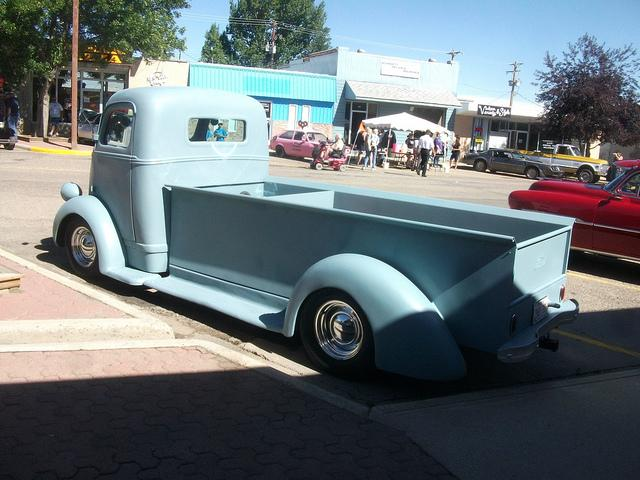What color is the strange old truck?

Choices:
A) turquoise
B) red
C) pink
D) gray turquoise 